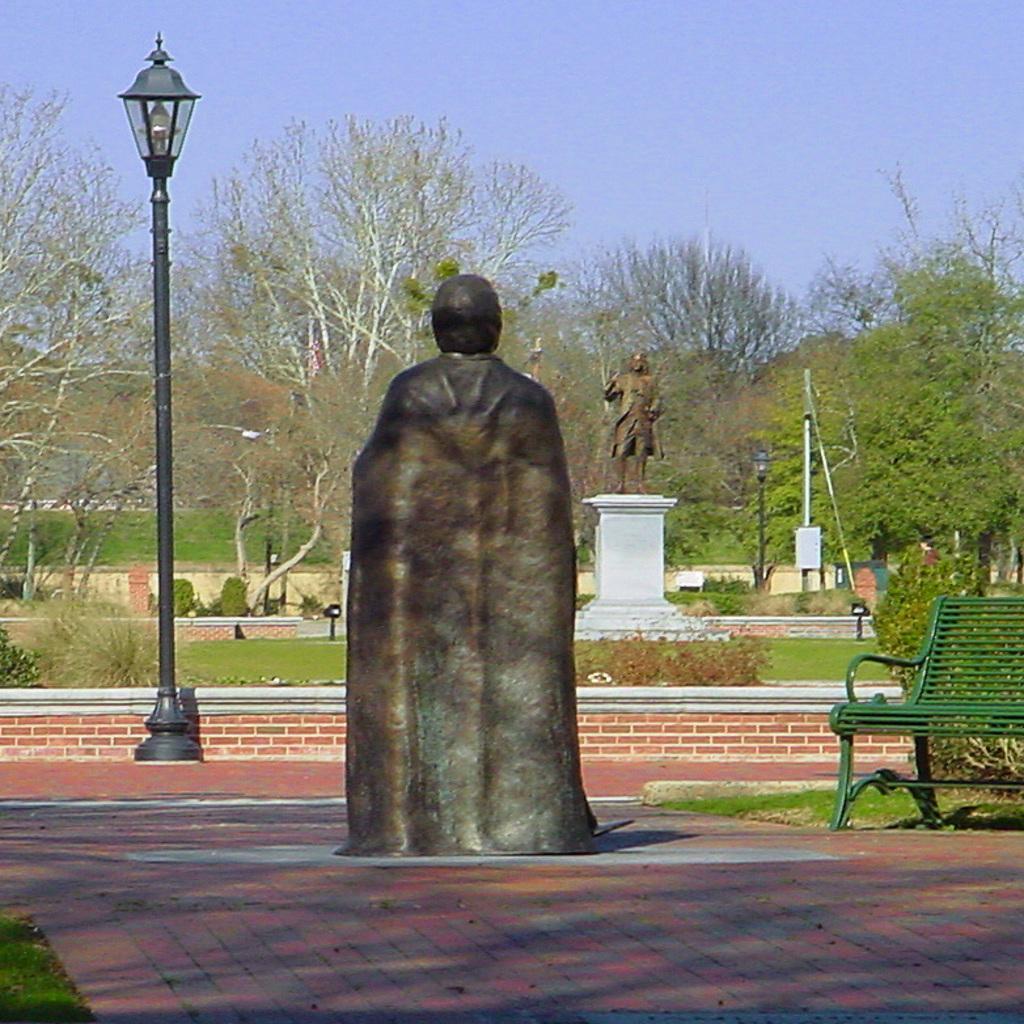Describe this image in one or two sentences. At the bottom of the image there is a floor. In the middle of the floor there is a statue. And on the right side of the image there is a bench. There is a pole with lamp. In the background there are trees and also there are plants and grass on the ground. In the middle of them there is a statue. At the top of the image there is a sky. 